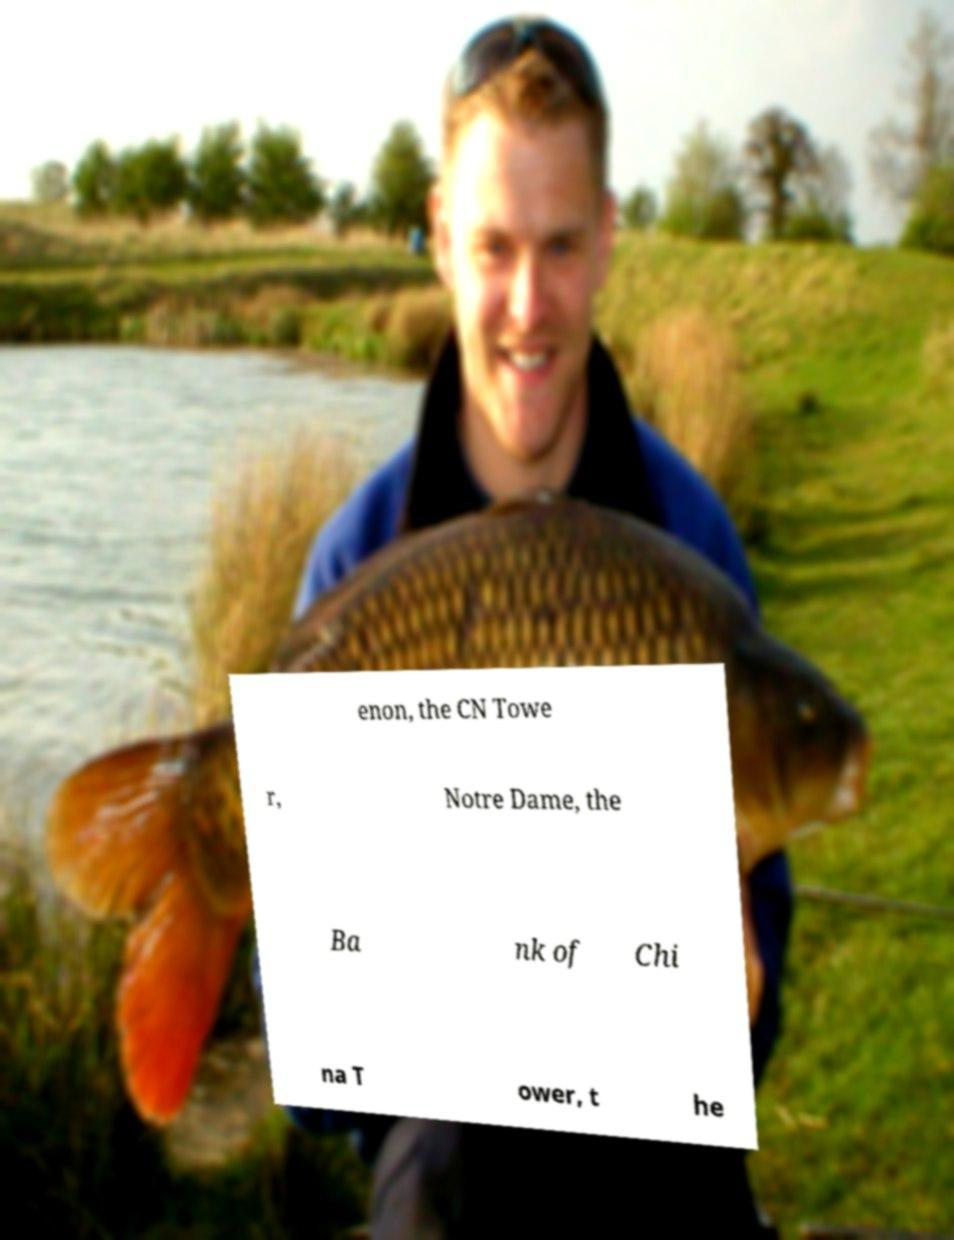I need the written content from this picture converted into text. Can you do that? enon, the CN Towe r, Notre Dame, the Ba nk of Chi na T ower, t he 